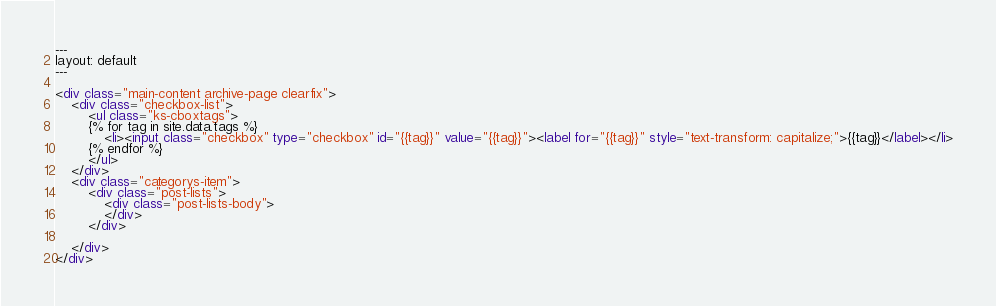<code> <loc_0><loc_0><loc_500><loc_500><_HTML_>---
layout: default
---

<div class="main-content archive-page clearfix">
    <div class="checkbox-list">
        <ul class="ks-cboxtags">
        {% for tag in site.data.tags %}
            <li><input class="checkbox" type="checkbox" id="{{tag}}" value="{{tag}}"><label for="{{tag}}" style="text-transform: capitalize;">{{tag}}</label></li>
        {% endfor %}
        </ul>
    </div>
    <div class="categorys-item">
        <div class="post-lists">
            <div class="post-lists-body">
            </div>
        </div>

    </div>
</div></code> 